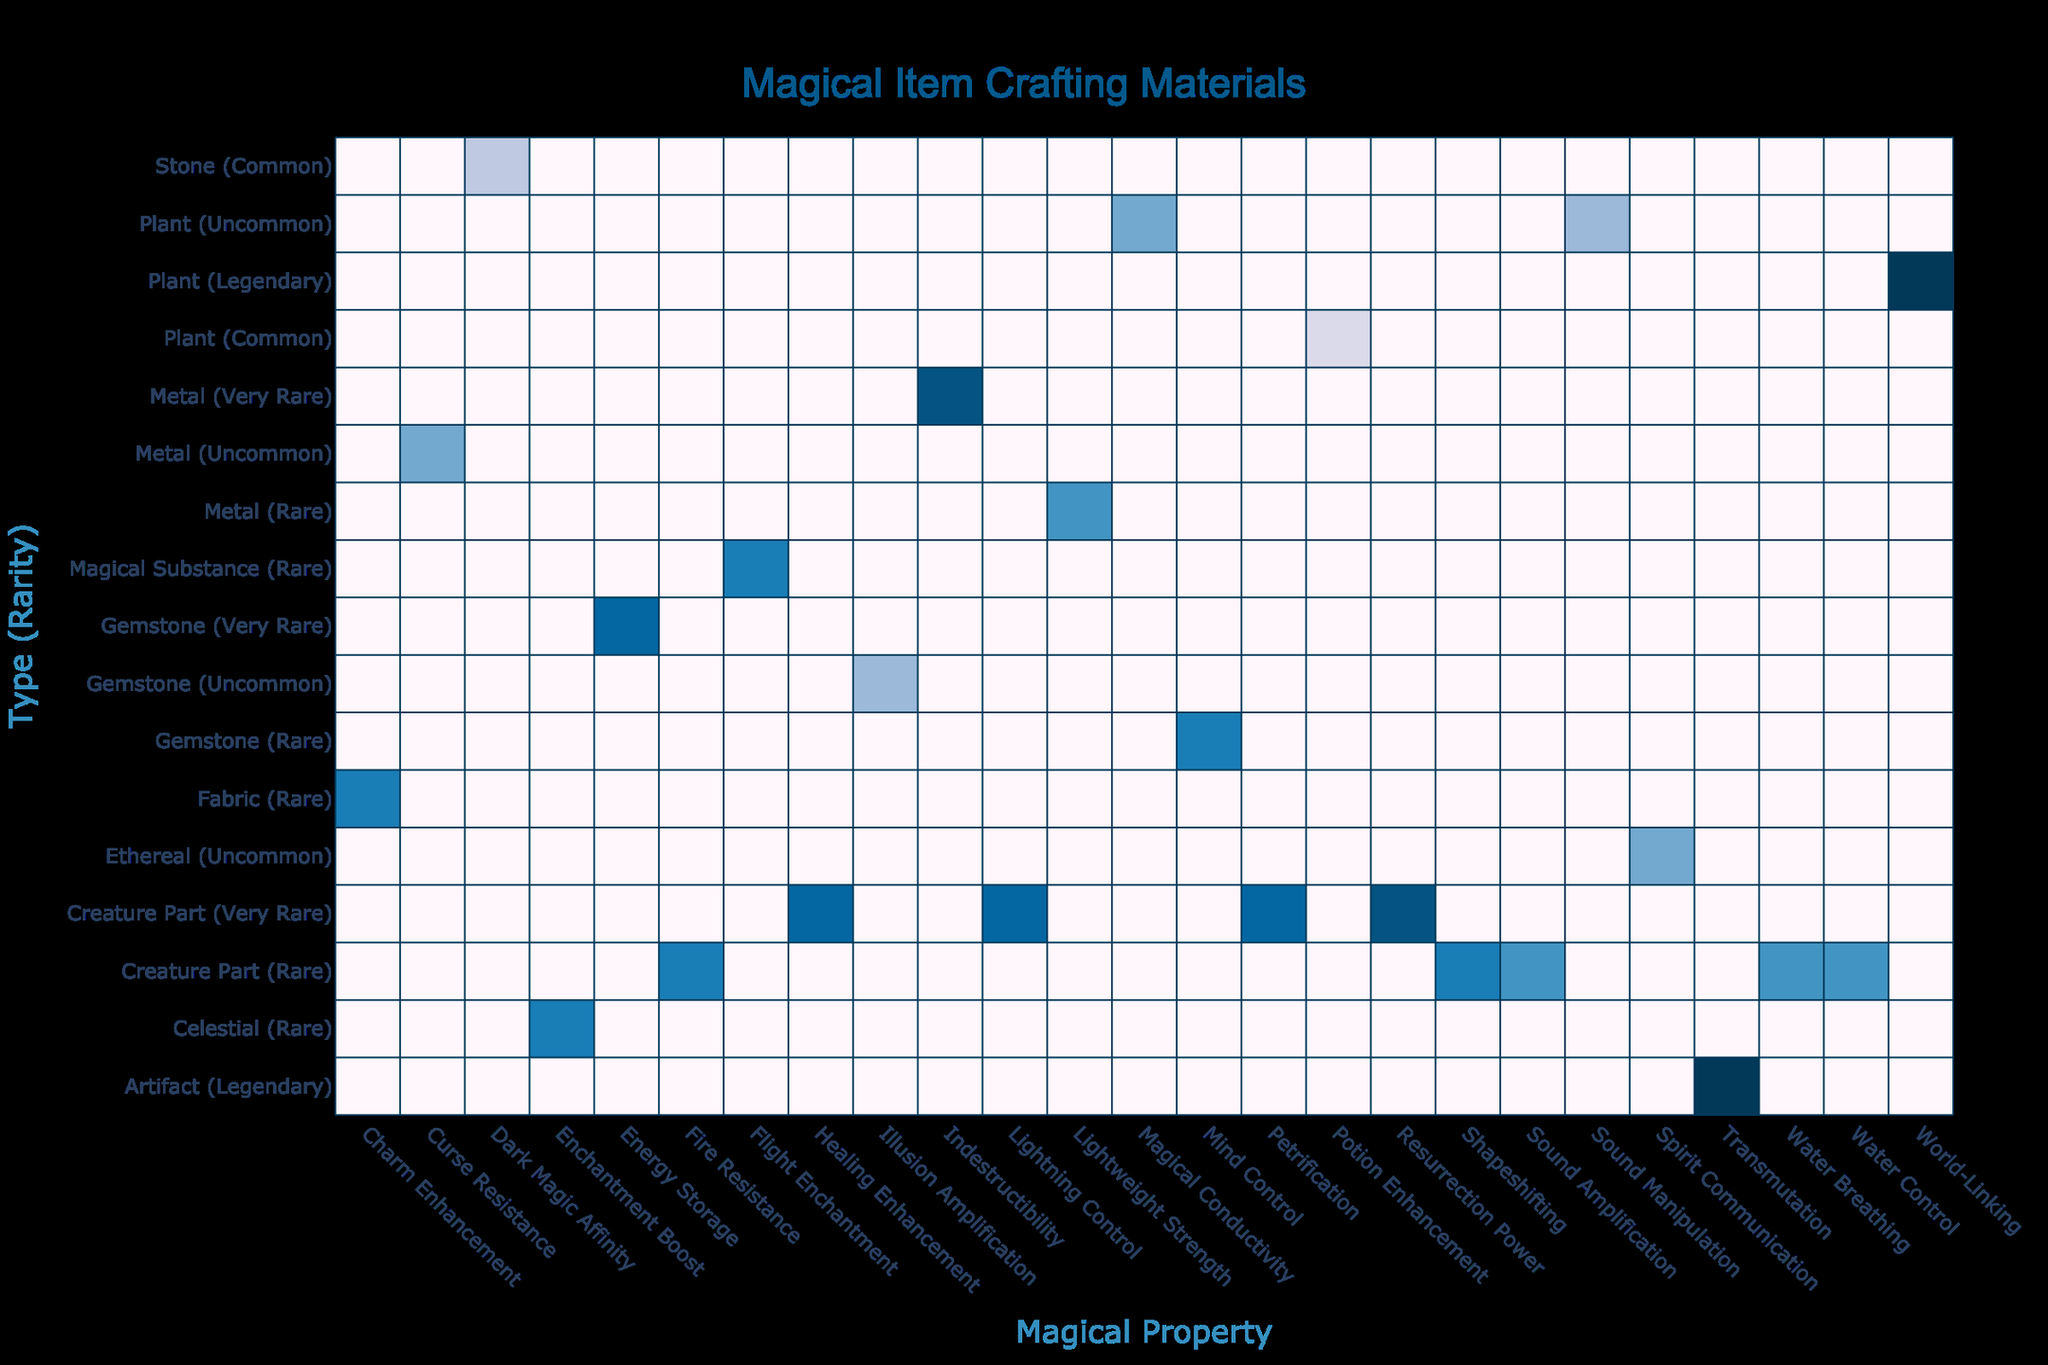What is the maximum power level of materials in the table? By examining the table, I look for the highest value listed under the "Power Level" column. The highest value is 10, which corresponds to the Philosopher's Stone and Yggdrasil Leaf.
Answer: 10 Which material has the property of "Water Control"? I scan the "Magical Property" column for "Water Control" and find it associated with Kraken Ink, which is categorized under "Creature Part" and is considered rare.
Answer: Kraken Ink Are there any common materials that have a magical property of "Potion Enhancement"? I check the "Rarity" column for any common materials and find that Witch Hazel has the magical property "Potion Enhancement," confirming that there is indeed one common material with this property.
Answer: Yes What is the average power level of very rare materials? To find the average power level of very rare materials, I gather the power levels of the following materials: Unicorn Hair (8), Phoenix Feather (9), Basilisk Venom (8), Adamantium (9), Thunderbird Feather (8), and Dragonfire Amber (8). The sum is 60, and there are 6 materials, so the average is 60/6 = 10.
Answer: 8.5 Which type of material has the highest average power level? First, I calculate the average power level for each type listed in the table. For example, Creature Parts average 7.5, Metals average 7, Gemstones average 6.33, and so forth. The highest average is found under the "Creature Part" category.
Answer: Creature Part Is there any material that provides both "Healing Enhancement" and is very rare? I search the table for the property "Healing Enhancement" and check the rarity. The Unicorn Hair has this property and is indeed classified as very rare, confirming the presence of such a material.
Answer: Yes What is the rarity of the material that enhances "Dark Magic Affinity"? I locate "Dark Magic Affinity" in the "Magical Property" column and find that it is linked to Obsidian, which falls under the common category regarding rarity.
Answer: Common Which material has both "Charm Enhancement" and is rare? I look for the magical property "Charm Enhancement" in the table and see that it is connected to Fae Silk, confirming it is categorized as a rare material.
Answer: Fae Silk 